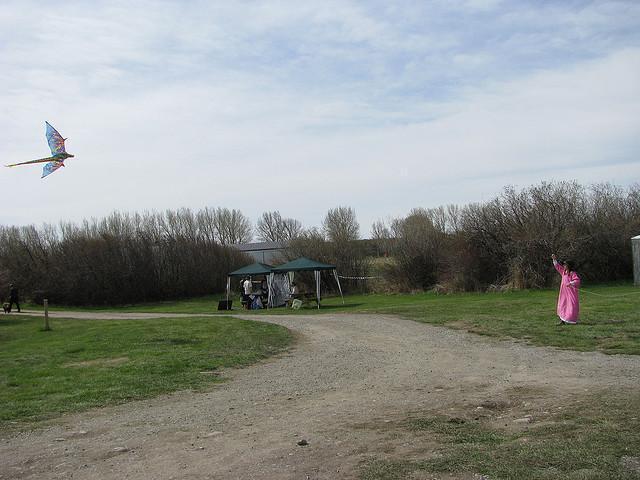How many tents are in the background?
Give a very brief answer. 2. How many kites are in the air?
Give a very brief answer. 1. How many red cars are driving on the road?
Give a very brief answer. 0. 